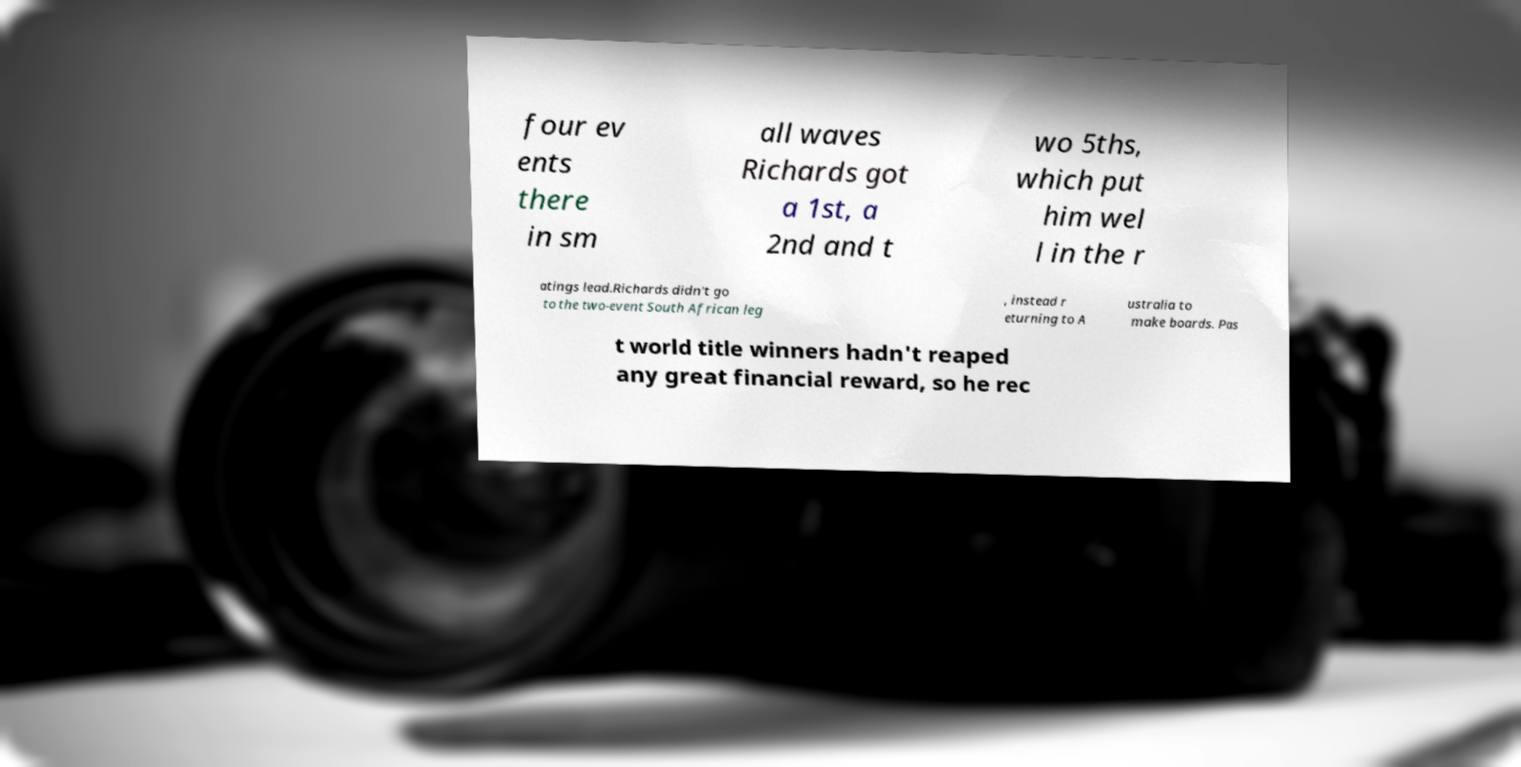What messages or text are displayed in this image? I need them in a readable, typed format. four ev ents there in sm all waves Richards got a 1st, a 2nd and t wo 5ths, which put him wel l in the r atings lead.Richards didn't go to the two-event South African leg , instead r eturning to A ustralia to make boards. Pas t world title winners hadn't reaped any great financial reward, so he rec 